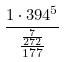<formula> <loc_0><loc_0><loc_500><loc_500>\frac { 1 \cdot 3 9 4 ^ { 5 } } { \frac { \frac { 7 } { 2 7 2 } } { 1 7 7 } }</formula> 